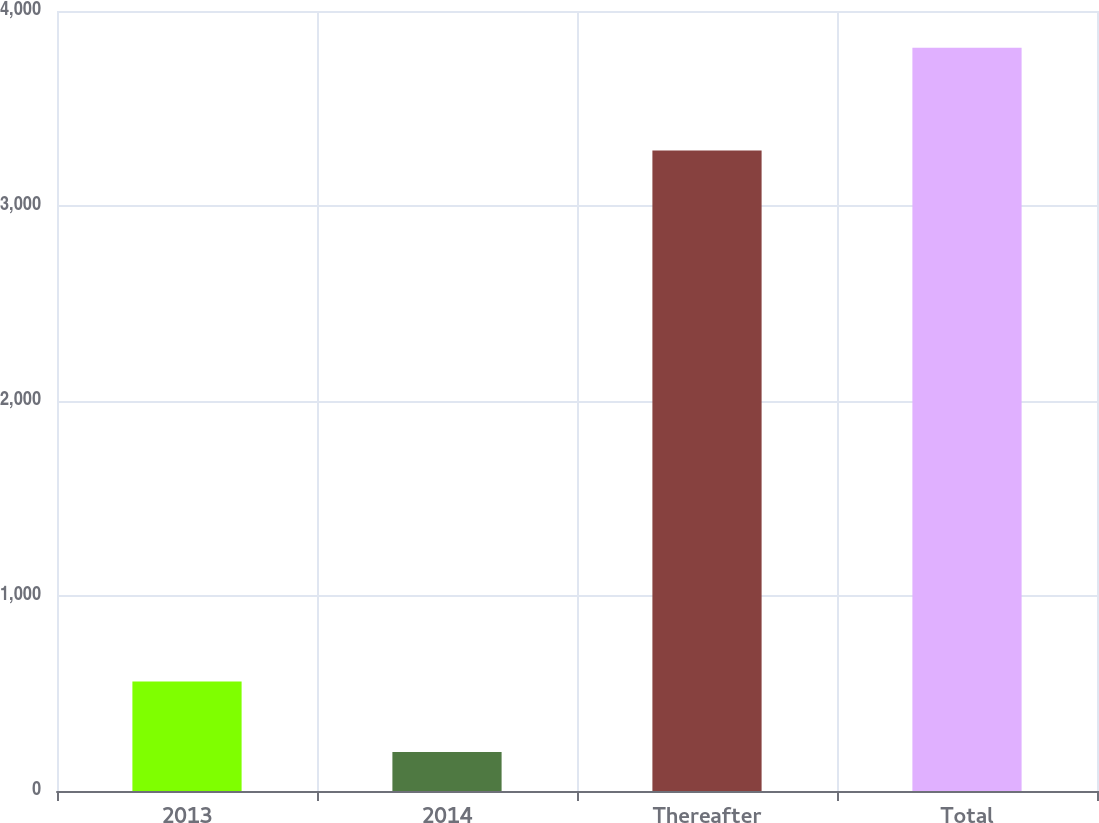Convert chart. <chart><loc_0><loc_0><loc_500><loc_500><bar_chart><fcel>2013<fcel>2014<fcel>Thereafter<fcel>Total<nl><fcel>561.2<fcel>200<fcel>3284<fcel>3812<nl></chart> 